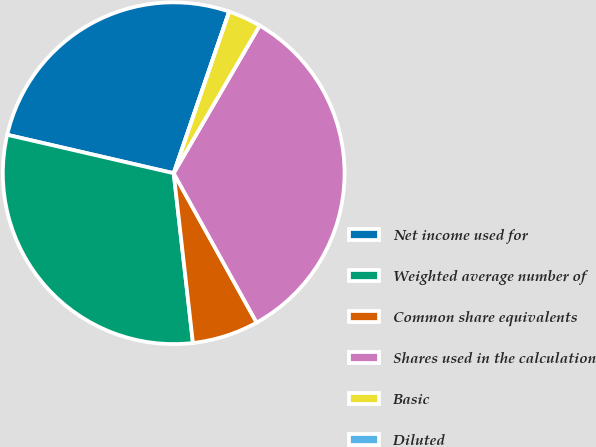Convert chart to OTSL. <chart><loc_0><loc_0><loc_500><loc_500><pie_chart><fcel>Net income used for<fcel>Weighted average number of<fcel>Common share equivalents<fcel>Shares used in the calculation<fcel>Basic<fcel>Diluted<nl><fcel>26.65%<fcel>30.41%<fcel>6.27%<fcel>33.54%<fcel>3.13%<fcel>0.0%<nl></chart> 